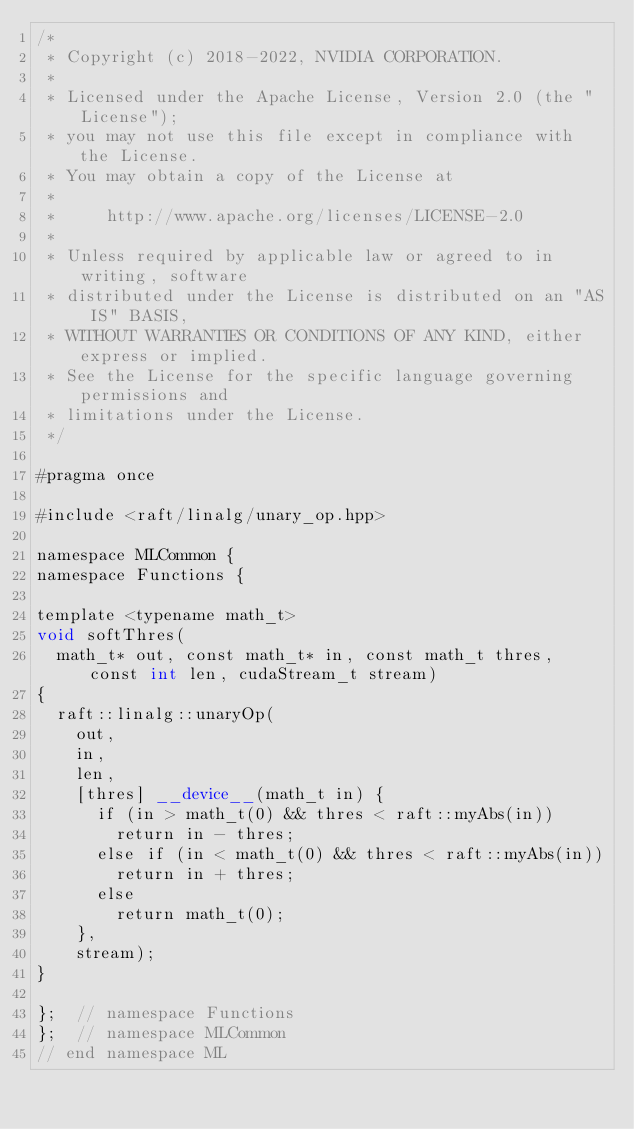<code> <loc_0><loc_0><loc_500><loc_500><_Cuda_>/*
 * Copyright (c) 2018-2022, NVIDIA CORPORATION.
 *
 * Licensed under the Apache License, Version 2.0 (the "License");
 * you may not use this file except in compliance with the License.
 * You may obtain a copy of the License at
 *
 *     http://www.apache.org/licenses/LICENSE-2.0
 *
 * Unless required by applicable law or agreed to in writing, software
 * distributed under the License is distributed on an "AS IS" BASIS,
 * WITHOUT WARRANTIES OR CONDITIONS OF ANY KIND, either express or implied.
 * See the License for the specific language governing permissions and
 * limitations under the License.
 */

#pragma once

#include <raft/linalg/unary_op.hpp>

namespace MLCommon {
namespace Functions {

template <typename math_t>
void softThres(
  math_t* out, const math_t* in, const math_t thres, const int len, cudaStream_t stream)
{
  raft::linalg::unaryOp(
    out,
    in,
    len,
    [thres] __device__(math_t in) {
      if (in > math_t(0) && thres < raft::myAbs(in))
        return in - thres;
      else if (in < math_t(0) && thres < raft::myAbs(in))
        return in + thres;
      else
        return math_t(0);
    },
    stream);
}

};  // namespace Functions
};  // namespace MLCommon
// end namespace ML
</code> 